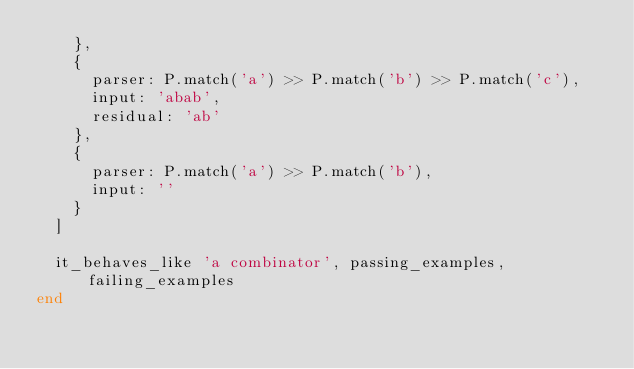<code> <loc_0><loc_0><loc_500><loc_500><_Ruby_>    },
    {
      parser: P.match('a') >> P.match('b') >> P.match('c'),
      input: 'abab',
      residual: 'ab'
    },
    {
      parser: P.match('a') >> P.match('b'),
      input: ''
    }
  ]

  it_behaves_like 'a combinator', passing_examples, failing_examples
end
</code> 